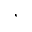Convert formula to latex. <formula><loc_0><loc_0><loc_500><loc_500>,</formula> 